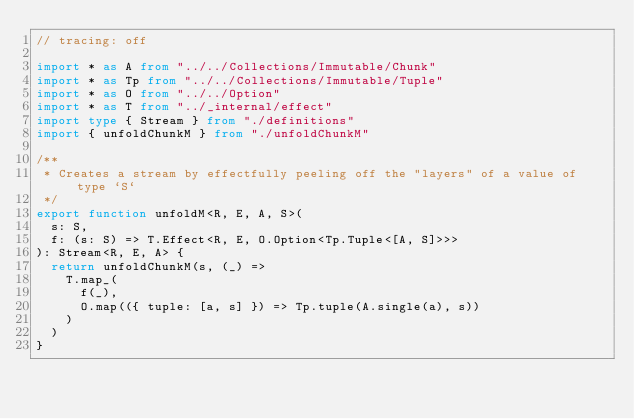<code> <loc_0><loc_0><loc_500><loc_500><_TypeScript_>// tracing: off

import * as A from "../../Collections/Immutable/Chunk"
import * as Tp from "../../Collections/Immutable/Tuple"
import * as O from "../../Option"
import * as T from "../_internal/effect"
import type { Stream } from "./definitions"
import { unfoldChunkM } from "./unfoldChunkM"

/**
 * Creates a stream by effectfully peeling off the "layers" of a value of type `S`
 */
export function unfoldM<R, E, A, S>(
  s: S,
  f: (s: S) => T.Effect<R, E, O.Option<Tp.Tuple<[A, S]>>>
): Stream<R, E, A> {
  return unfoldChunkM(s, (_) =>
    T.map_(
      f(_),
      O.map(({ tuple: [a, s] }) => Tp.tuple(A.single(a), s))
    )
  )
}
</code> 